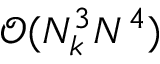<formula> <loc_0><loc_0><loc_500><loc_500>\mathcal { O } ( N _ { k } ^ { 3 } N ^ { 4 } )</formula> 